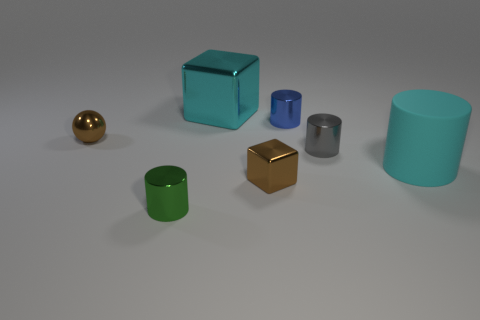Can you describe the different materials that the objects in the image appear to be made of? Certainly! The objects in the image seem to represent various materials. The golden sphere and the silver cylinder give off shiny reflections, indicative of metallic surfaces. The cubes and cylindrical objects have matte surfaces that could resemble plastic or some form of polished stone with a less reflective quality. Each one's texture contributes to the overall impression of the assorted materials they might represent. 